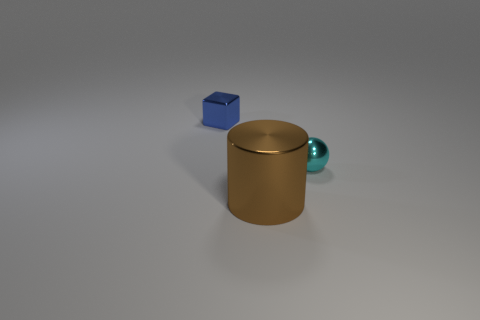Add 3 blue objects. How many objects exist? 6 Subtract all cubes. How many objects are left? 2 Subtract all big cylinders. Subtract all tiny shiny spheres. How many objects are left? 1 Add 1 small blue shiny cubes. How many small blue shiny cubes are left? 2 Add 3 tiny yellow matte balls. How many tiny yellow matte balls exist? 3 Subtract 0 purple cylinders. How many objects are left? 3 